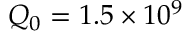Convert formula to latex. <formula><loc_0><loc_0><loc_500><loc_500>Q _ { 0 } = 1 . 5 \times 1 0 ^ { 9 }</formula> 